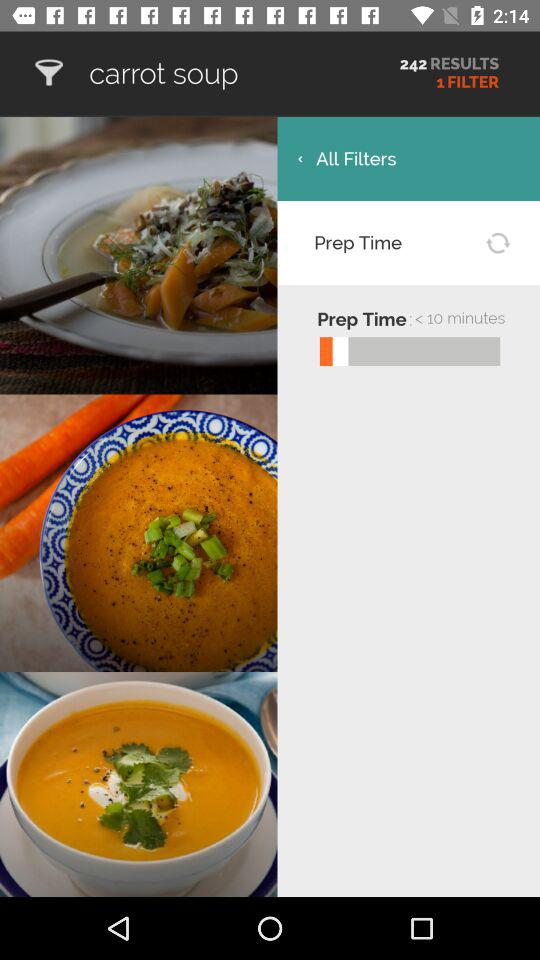How many results are there? There are 242 results. 